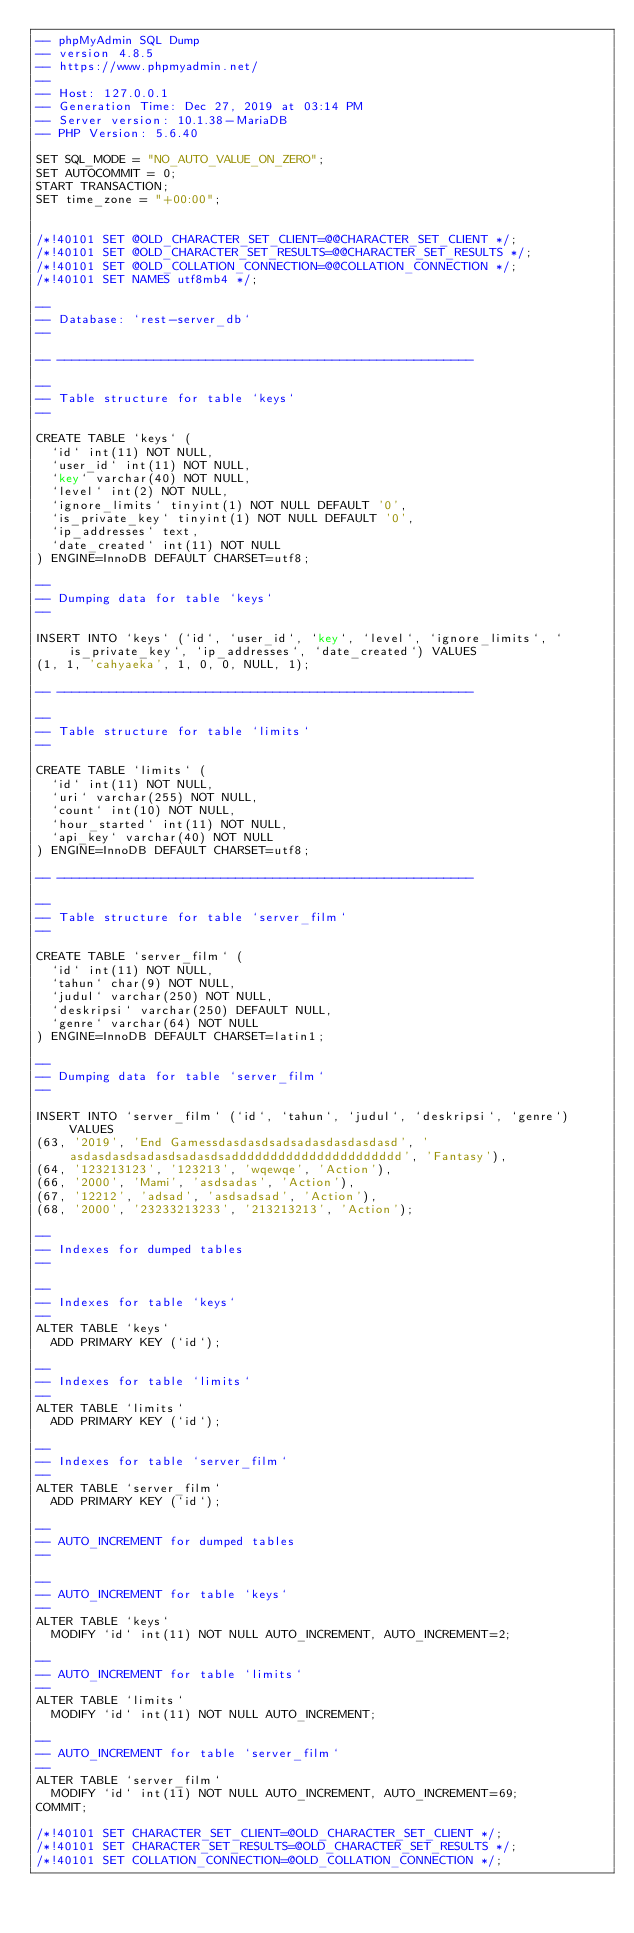Convert code to text. <code><loc_0><loc_0><loc_500><loc_500><_SQL_>-- phpMyAdmin SQL Dump
-- version 4.8.5
-- https://www.phpmyadmin.net/
--
-- Host: 127.0.0.1
-- Generation Time: Dec 27, 2019 at 03:14 PM
-- Server version: 10.1.38-MariaDB
-- PHP Version: 5.6.40

SET SQL_MODE = "NO_AUTO_VALUE_ON_ZERO";
SET AUTOCOMMIT = 0;
START TRANSACTION;
SET time_zone = "+00:00";


/*!40101 SET @OLD_CHARACTER_SET_CLIENT=@@CHARACTER_SET_CLIENT */;
/*!40101 SET @OLD_CHARACTER_SET_RESULTS=@@CHARACTER_SET_RESULTS */;
/*!40101 SET @OLD_COLLATION_CONNECTION=@@COLLATION_CONNECTION */;
/*!40101 SET NAMES utf8mb4 */;

--
-- Database: `rest-server_db`
--

-- --------------------------------------------------------

--
-- Table structure for table `keys`
--

CREATE TABLE `keys` (
  `id` int(11) NOT NULL,
  `user_id` int(11) NOT NULL,
  `key` varchar(40) NOT NULL,
  `level` int(2) NOT NULL,
  `ignore_limits` tinyint(1) NOT NULL DEFAULT '0',
  `is_private_key` tinyint(1) NOT NULL DEFAULT '0',
  `ip_addresses` text,
  `date_created` int(11) NOT NULL
) ENGINE=InnoDB DEFAULT CHARSET=utf8;

--
-- Dumping data for table `keys`
--

INSERT INTO `keys` (`id`, `user_id`, `key`, `level`, `ignore_limits`, `is_private_key`, `ip_addresses`, `date_created`) VALUES
(1, 1, 'cahyaeka', 1, 0, 0, NULL, 1);

-- --------------------------------------------------------

--
-- Table structure for table `limits`
--

CREATE TABLE `limits` (
  `id` int(11) NOT NULL,
  `uri` varchar(255) NOT NULL,
  `count` int(10) NOT NULL,
  `hour_started` int(11) NOT NULL,
  `api_key` varchar(40) NOT NULL
) ENGINE=InnoDB DEFAULT CHARSET=utf8;

-- --------------------------------------------------------

--
-- Table structure for table `server_film`
--

CREATE TABLE `server_film` (
  `id` int(11) NOT NULL,
  `tahun` char(9) NOT NULL,
  `judul` varchar(250) NOT NULL,
  `deskripsi` varchar(250) DEFAULT NULL,
  `genre` varchar(64) NOT NULL
) ENGINE=InnoDB DEFAULT CHARSET=latin1;

--
-- Dumping data for table `server_film`
--

INSERT INTO `server_film` (`id`, `tahun`, `judul`, `deskripsi`, `genre`) VALUES
(63, '2019', 'End Gamessdasdasdsadsadasdasdasdasd', 'asdasdasdsadasdsadasdsadddddddddddddddddddddd', 'Fantasy'),
(64, '123213123', '123213', 'wqewqe', 'Action'),
(66, '2000', 'Mami', 'asdsadas', 'Action'),
(67, '12212', 'adsad', 'asdsadsad', 'Action'),
(68, '2000', '23233213233', '213213213', 'Action');

--
-- Indexes for dumped tables
--

--
-- Indexes for table `keys`
--
ALTER TABLE `keys`
  ADD PRIMARY KEY (`id`);

--
-- Indexes for table `limits`
--
ALTER TABLE `limits`
  ADD PRIMARY KEY (`id`);

--
-- Indexes for table `server_film`
--
ALTER TABLE `server_film`
  ADD PRIMARY KEY (`id`);

--
-- AUTO_INCREMENT for dumped tables
--

--
-- AUTO_INCREMENT for table `keys`
--
ALTER TABLE `keys`
  MODIFY `id` int(11) NOT NULL AUTO_INCREMENT, AUTO_INCREMENT=2;

--
-- AUTO_INCREMENT for table `limits`
--
ALTER TABLE `limits`
  MODIFY `id` int(11) NOT NULL AUTO_INCREMENT;

--
-- AUTO_INCREMENT for table `server_film`
--
ALTER TABLE `server_film`
  MODIFY `id` int(11) NOT NULL AUTO_INCREMENT, AUTO_INCREMENT=69;
COMMIT;

/*!40101 SET CHARACTER_SET_CLIENT=@OLD_CHARACTER_SET_CLIENT */;
/*!40101 SET CHARACTER_SET_RESULTS=@OLD_CHARACTER_SET_RESULTS */;
/*!40101 SET COLLATION_CONNECTION=@OLD_COLLATION_CONNECTION */;
</code> 